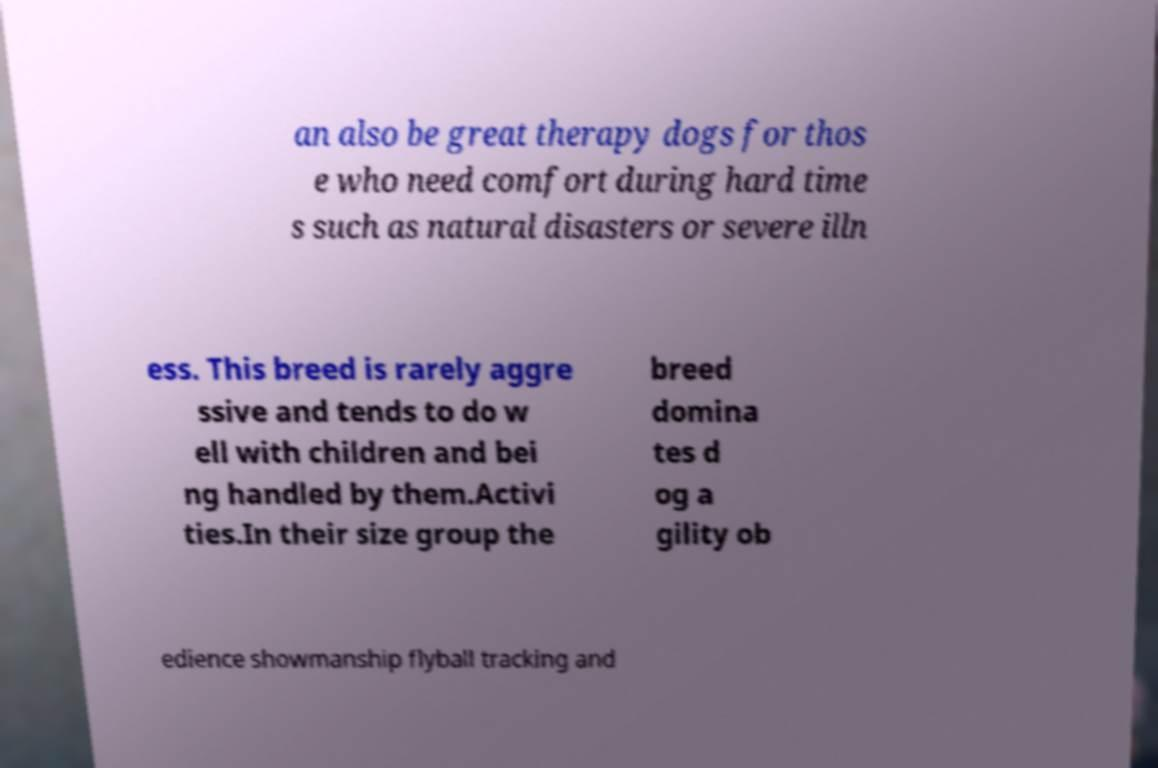Could you assist in decoding the text presented in this image and type it out clearly? an also be great therapy dogs for thos e who need comfort during hard time s such as natural disasters or severe illn ess. This breed is rarely aggre ssive and tends to do w ell with children and bei ng handled by them.Activi ties.In their size group the breed domina tes d og a gility ob edience showmanship flyball tracking and 